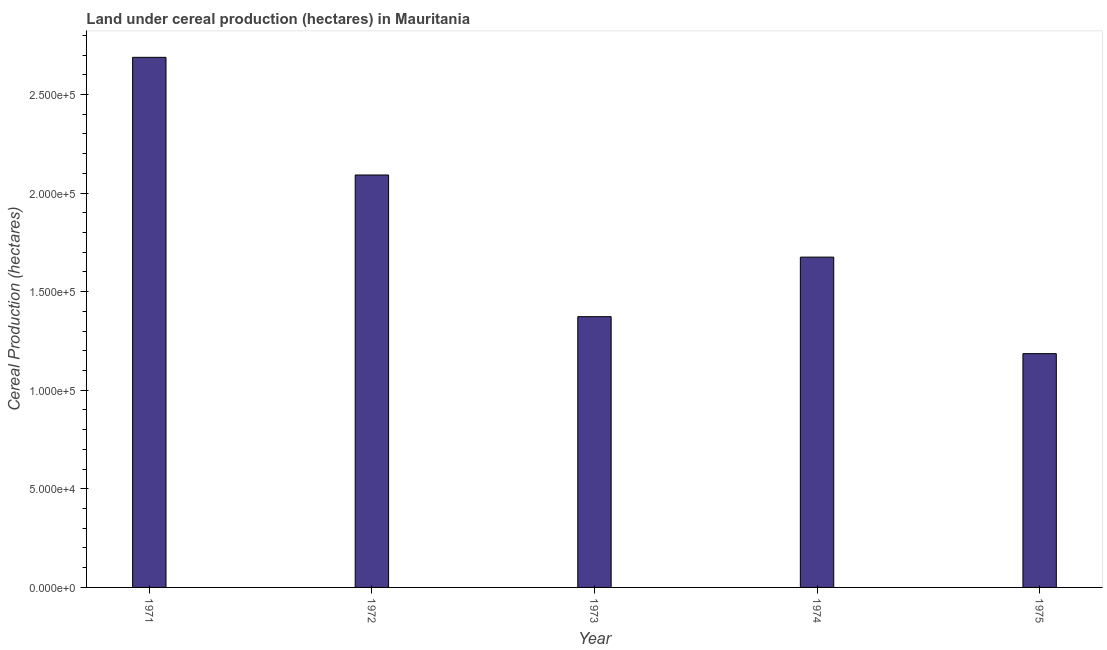Does the graph contain any zero values?
Give a very brief answer. No. What is the title of the graph?
Your answer should be very brief. Land under cereal production (hectares) in Mauritania. What is the label or title of the X-axis?
Ensure brevity in your answer.  Year. What is the label or title of the Y-axis?
Your answer should be compact. Cereal Production (hectares). What is the land under cereal production in 1974?
Your answer should be compact. 1.68e+05. Across all years, what is the maximum land under cereal production?
Ensure brevity in your answer.  2.69e+05. Across all years, what is the minimum land under cereal production?
Make the answer very short. 1.19e+05. In which year was the land under cereal production maximum?
Give a very brief answer. 1971. In which year was the land under cereal production minimum?
Your answer should be very brief. 1975. What is the sum of the land under cereal production?
Provide a succinct answer. 9.01e+05. What is the difference between the land under cereal production in 1972 and 1974?
Provide a short and direct response. 4.16e+04. What is the average land under cereal production per year?
Offer a terse response. 1.80e+05. What is the median land under cereal production?
Your answer should be very brief. 1.68e+05. What is the ratio of the land under cereal production in 1971 to that in 1973?
Offer a very short reply. 1.96. Is the land under cereal production in 1971 less than that in 1974?
Provide a short and direct response. No. What is the difference between the highest and the second highest land under cereal production?
Your answer should be very brief. 5.97e+04. What is the difference between the highest and the lowest land under cereal production?
Provide a succinct answer. 1.50e+05. Are all the bars in the graph horizontal?
Keep it short and to the point. No. How many years are there in the graph?
Ensure brevity in your answer.  5. What is the difference between two consecutive major ticks on the Y-axis?
Give a very brief answer. 5.00e+04. What is the Cereal Production (hectares) of 1971?
Offer a very short reply. 2.69e+05. What is the Cereal Production (hectares) in 1972?
Make the answer very short. 2.09e+05. What is the Cereal Production (hectares) of 1973?
Your answer should be compact. 1.37e+05. What is the Cereal Production (hectares) in 1974?
Your answer should be compact. 1.68e+05. What is the Cereal Production (hectares) of 1975?
Your answer should be very brief. 1.19e+05. What is the difference between the Cereal Production (hectares) in 1971 and 1972?
Give a very brief answer. 5.97e+04. What is the difference between the Cereal Production (hectares) in 1971 and 1973?
Ensure brevity in your answer.  1.32e+05. What is the difference between the Cereal Production (hectares) in 1971 and 1974?
Give a very brief answer. 1.01e+05. What is the difference between the Cereal Production (hectares) in 1971 and 1975?
Your answer should be very brief. 1.50e+05. What is the difference between the Cereal Production (hectares) in 1972 and 1973?
Your answer should be compact. 7.18e+04. What is the difference between the Cereal Production (hectares) in 1972 and 1974?
Give a very brief answer. 4.16e+04. What is the difference between the Cereal Production (hectares) in 1972 and 1975?
Provide a short and direct response. 9.06e+04. What is the difference between the Cereal Production (hectares) in 1973 and 1974?
Your answer should be very brief. -3.02e+04. What is the difference between the Cereal Production (hectares) in 1973 and 1975?
Your answer should be very brief. 1.87e+04. What is the difference between the Cereal Production (hectares) in 1974 and 1975?
Provide a short and direct response. 4.89e+04. What is the ratio of the Cereal Production (hectares) in 1971 to that in 1972?
Give a very brief answer. 1.28. What is the ratio of the Cereal Production (hectares) in 1971 to that in 1973?
Make the answer very short. 1.96. What is the ratio of the Cereal Production (hectares) in 1971 to that in 1974?
Your response must be concise. 1.6. What is the ratio of the Cereal Production (hectares) in 1971 to that in 1975?
Keep it short and to the point. 2.27. What is the ratio of the Cereal Production (hectares) in 1972 to that in 1973?
Provide a short and direct response. 1.52. What is the ratio of the Cereal Production (hectares) in 1972 to that in 1974?
Your answer should be compact. 1.25. What is the ratio of the Cereal Production (hectares) in 1972 to that in 1975?
Offer a very short reply. 1.76. What is the ratio of the Cereal Production (hectares) in 1973 to that in 1974?
Ensure brevity in your answer.  0.82. What is the ratio of the Cereal Production (hectares) in 1973 to that in 1975?
Offer a terse response. 1.16. What is the ratio of the Cereal Production (hectares) in 1974 to that in 1975?
Your answer should be very brief. 1.41. 